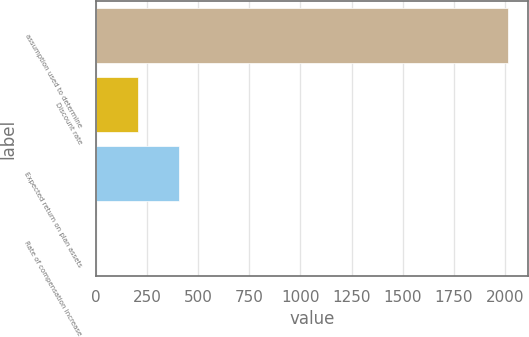Convert chart to OTSL. <chart><loc_0><loc_0><loc_500><loc_500><bar_chart><fcel>assumption used to determine<fcel>Discount rate<fcel>Expected return on plan assets<fcel>Rate of compensation increase<nl><fcel>2013<fcel>203.76<fcel>404.79<fcel>2.73<nl></chart> 